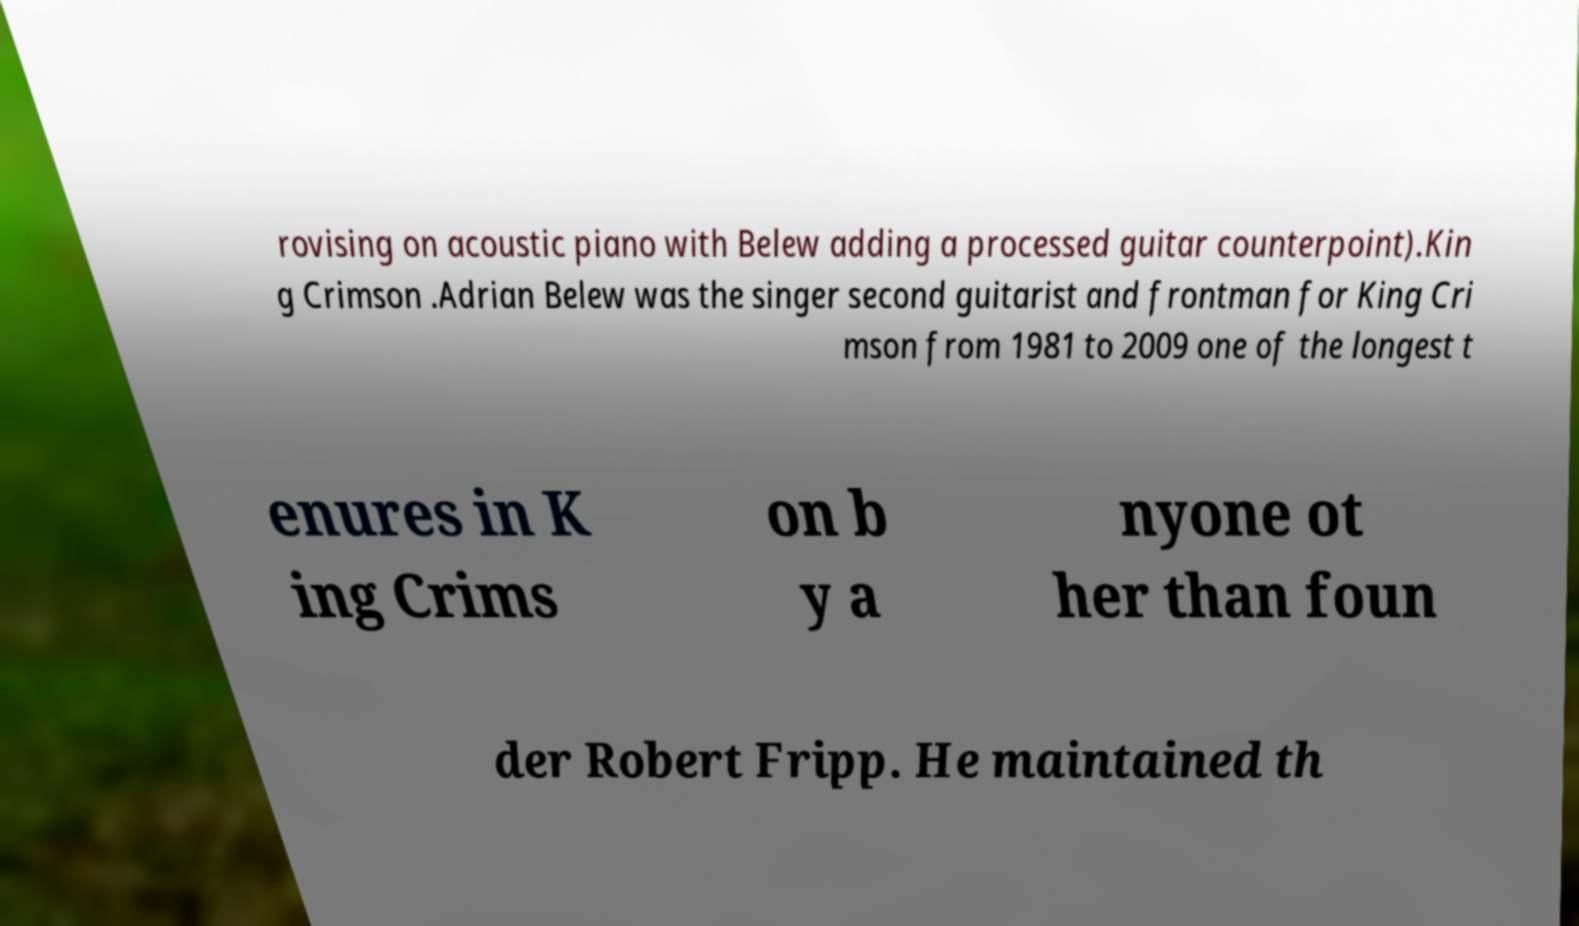Please identify and transcribe the text found in this image. rovising on acoustic piano with Belew adding a processed guitar counterpoint).Kin g Crimson .Adrian Belew was the singer second guitarist and frontman for King Cri mson from 1981 to 2009 one of the longest t enures in K ing Crims on b y a nyone ot her than foun der Robert Fripp. He maintained th 